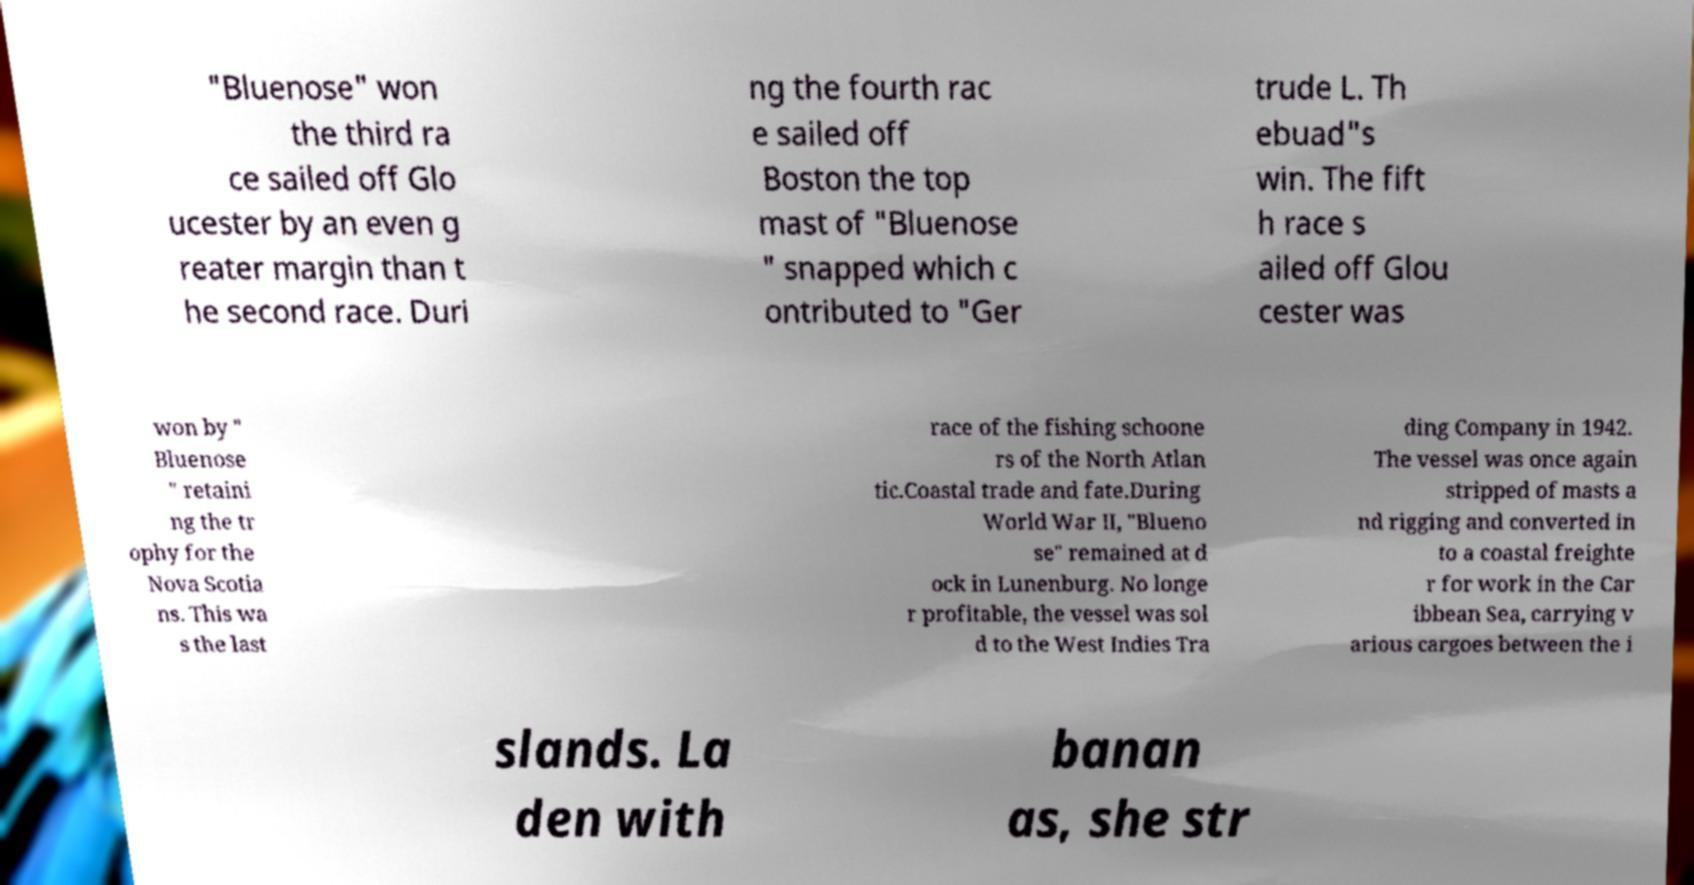Please read and relay the text visible in this image. What does it say? "Bluenose" won the third ra ce sailed off Glo ucester by an even g reater margin than t he second race. Duri ng the fourth rac e sailed off Boston the top mast of "Bluenose " snapped which c ontributed to "Ger trude L. Th ebuad"s win. The fift h race s ailed off Glou cester was won by " Bluenose " retaini ng the tr ophy for the Nova Scotia ns. This wa s the last race of the fishing schoone rs of the North Atlan tic.Coastal trade and fate.During World War II, "Blueno se" remained at d ock in Lunenburg. No longe r profitable, the vessel was sol d to the West Indies Tra ding Company in 1942. The vessel was once again stripped of masts a nd rigging and converted in to a coastal freighte r for work in the Car ibbean Sea, carrying v arious cargoes between the i slands. La den with banan as, she str 